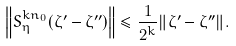Convert formula to latex. <formula><loc_0><loc_0><loc_500><loc_500>\left \| S _ { \eta } ^ { k n _ { 0 } } ( \zeta ^ { \prime } - \zeta ^ { \prime \prime } ) \right \| \leq \frac { 1 } { 2 ^ { k } } \| \zeta ^ { \prime } - \zeta ^ { \prime \prime } \| .</formula> 